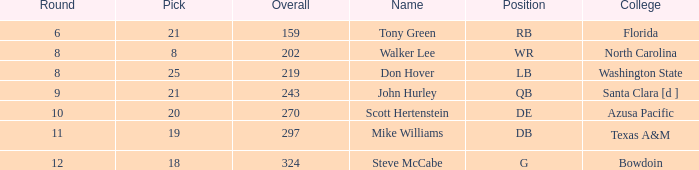What is the average overall that has a pick less than 20, North Carolina as the college, with a round less than 8? None. Could you parse the entire table as a dict? {'header': ['Round', 'Pick', 'Overall', 'Name', 'Position', 'College'], 'rows': [['6', '21', '159', 'Tony Green', 'RB', 'Florida'], ['8', '8', '202', 'Walker Lee', 'WR', 'North Carolina'], ['8', '25', '219', 'Don Hover', 'LB', 'Washington State'], ['9', '21', '243', 'John Hurley', 'QB', 'Santa Clara [d ]'], ['10', '20', '270', 'Scott Hertenstein', 'DE', 'Azusa Pacific'], ['11', '19', '297', 'Mike Williams', 'DB', 'Texas A&M'], ['12', '18', '324', 'Steve McCabe', 'G', 'Bowdoin']]} 